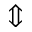<formula> <loc_0><loc_0><loc_500><loc_500>\Updownarrow</formula> 